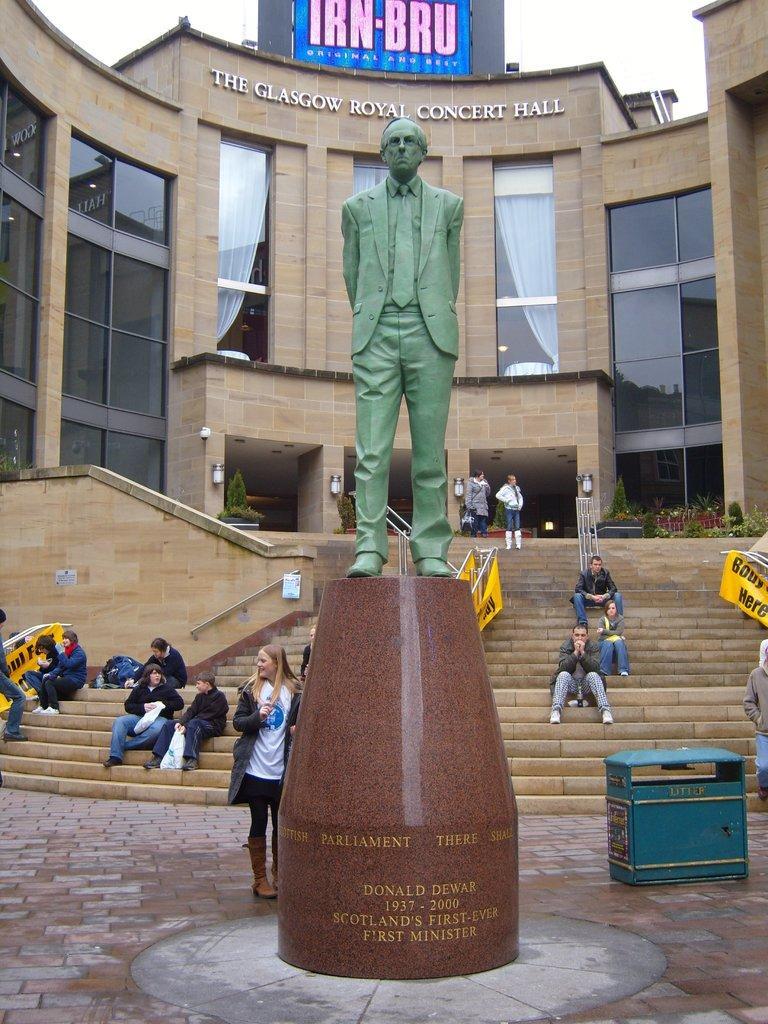Could you give a brief overview of what you see in this image? In this picture I can see in the middle there is a statue, few persons are sitting on the stairs. In the background there is a building. At the top there is the sky. 